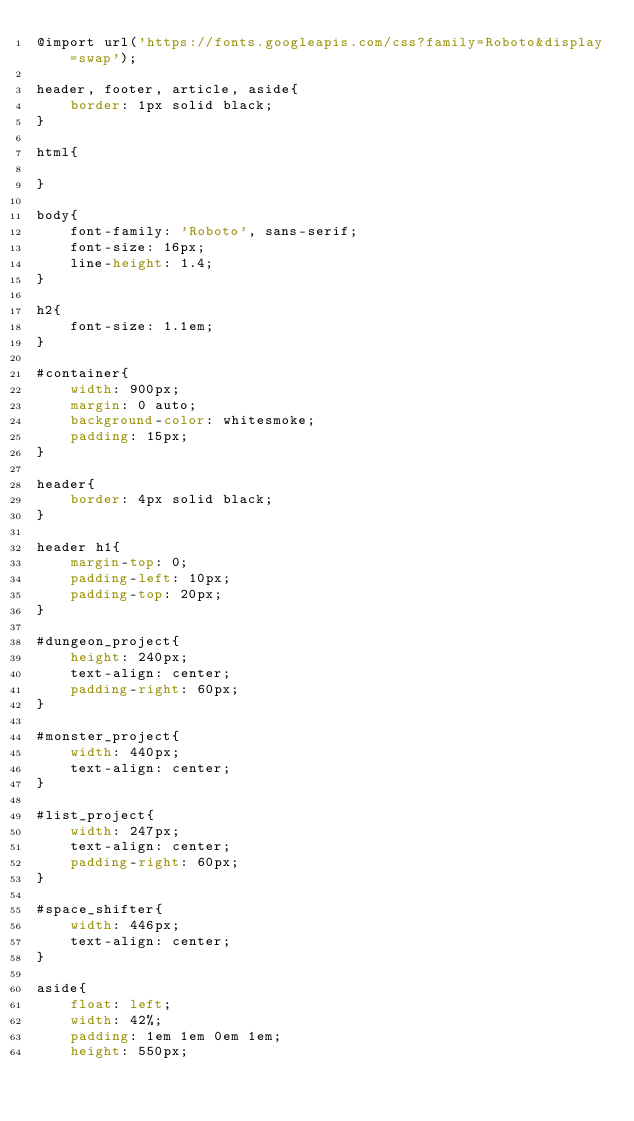Convert code to text. <code><loc_0><loc_0><loc_500><loc_500><_CSS_>@import url('https://fonts.googleapis.com/css?family=Roboto&display=swap');

header, footer, article, aside{
    border: 1px solid black;
}

html{
    
}

body{
    font-family: 'Roboto', sans-serif;
    font-size: 16px;
    line-height: 1.4;
}

h2{
    font-size: 1.1em;
}

#container{
    width: 900px;
    margin: 0 auto;
    background-color: whitesmoke;
    padding: 15px;
}

header{
    border: 4px solid black;
}

header h1{
    margin-top: 0;
    padding-left: 10px;
    padding-top: 20px;
}

#dungeon_project{
    height: 240px;
    text-align: center;
    padding-right: 60px;
}

#monster_project{
    width: 440px;
    text-align: center;
}

#list_project{
    width: 247px;
    text-align: center;
    padding-right: 60px;
}

#space_shifter{
    width: 446px;
    text-align: center;
}

aside{
    float: left;
    width: 42%;
    padding: 1em 1em 0em 1em;
    height: 550px;</code> 